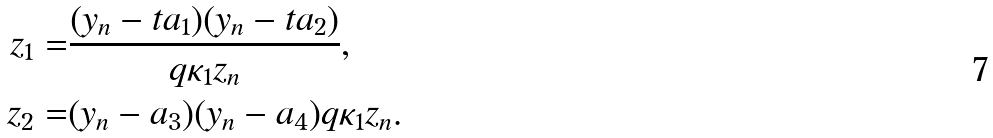Convert formula to latex. <formula><loc_0><loc_0><loc_500><loc_500>z _ { 1 } = & \frac { ( y _ { n } - t a _ { 1 } ) ( y _ { n } - t a _ { 2 } ) } { q \kappa _ { 1 } z _ { n } } , \\ z _ { 2 } = & ( y _ { n } - a _ { 3 } ) ( y _ { n } - a _ { 4 } ) q \kappa _ { 1 } z _ { n } .</formula> 